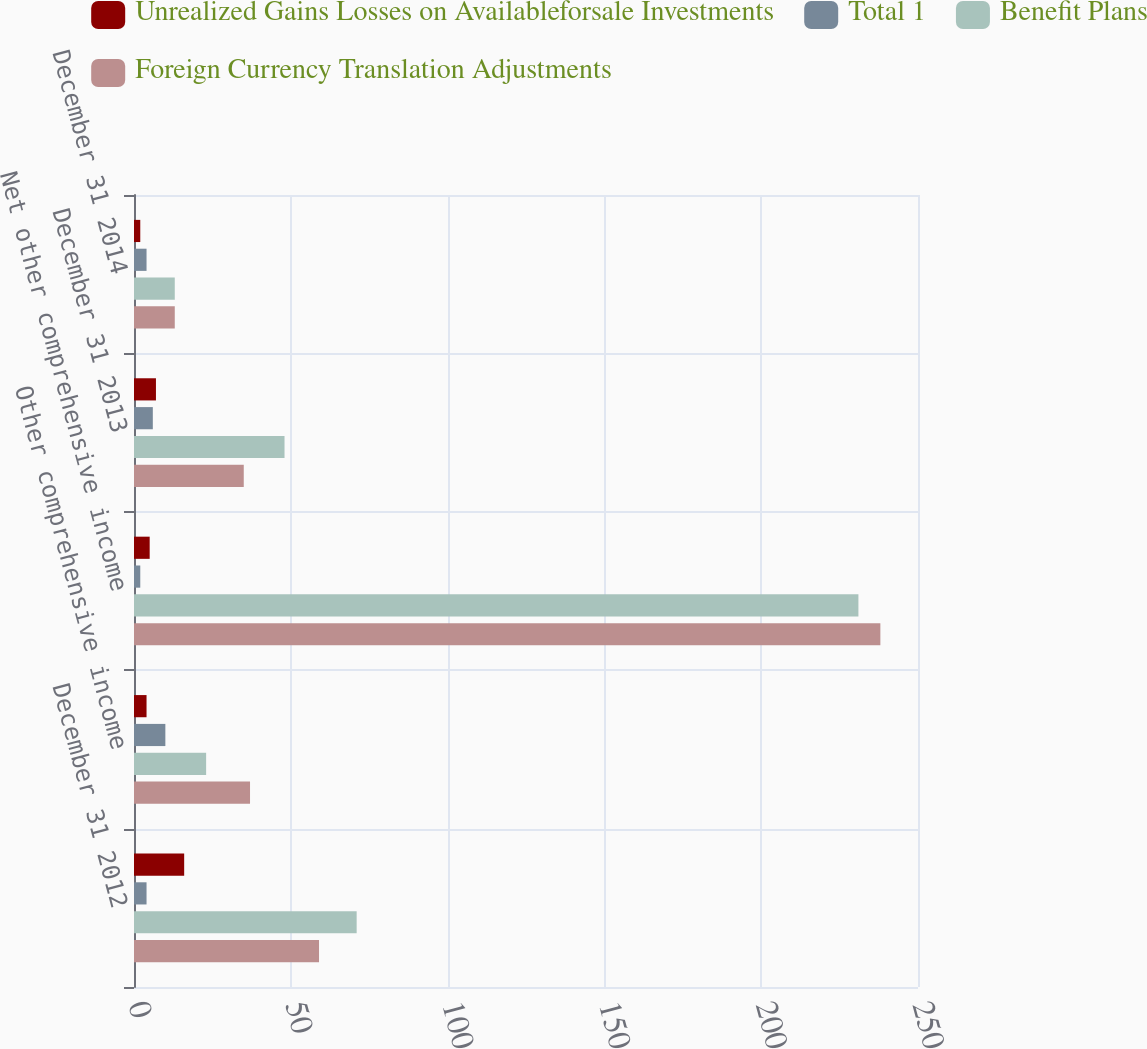<chart> <loc_0><loc_0><loc_500><loc_500><stacked_bar_chart><ecel><fcel>December 31 2012<fcel>Other comprehensive income<fcel>Net other comprehensive income<fcel>December 31 2013<fcel>December 31 2014<nl><fcel>Unrealized Gains Losses on Availableforsale Investments<fcel>16<fcel>4<fcel>5<fcel>7<fcel>2<nl><fcel>Total 1<fcel>4<fcel>10<fcel>2<fcel>6<fcel>4<nl><fcel>Benefit Plans<fcel>71<fcel>23<fcel>231<fcel>48<fcel>13<nl><fcel>Foreign Currency Translation Adjustments<fcel>59<fcel>37<fcel>238<fcel>35<fcel>13<nl></chart> 